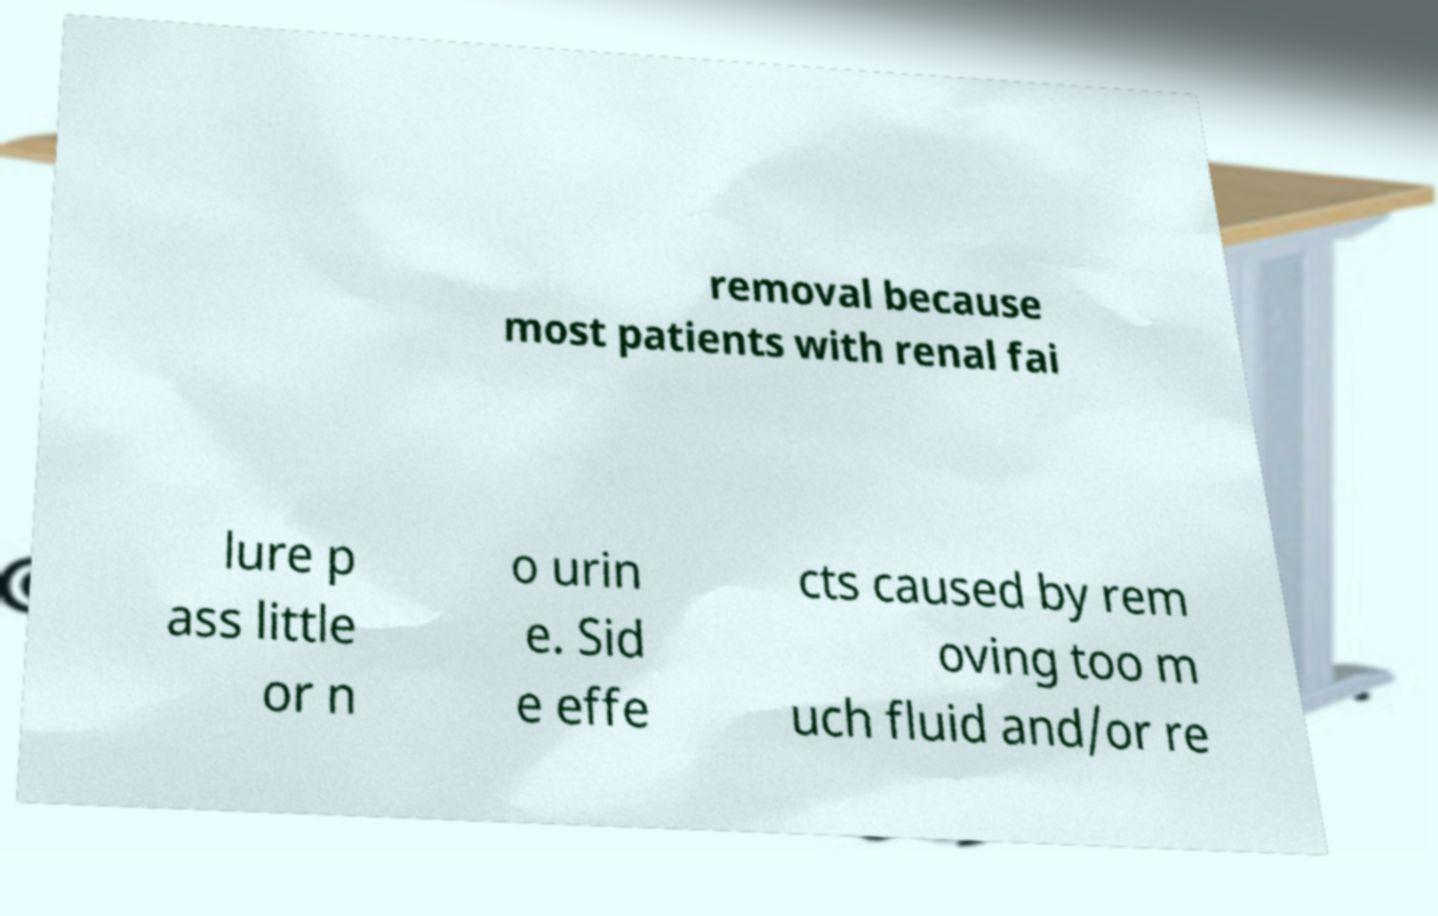Could you extract and type out the text from this image? removal because most patients with renal fai lure p ass little or n o urin e. Sid e effe cts caused by rem oving too m uch fluid and/or re 